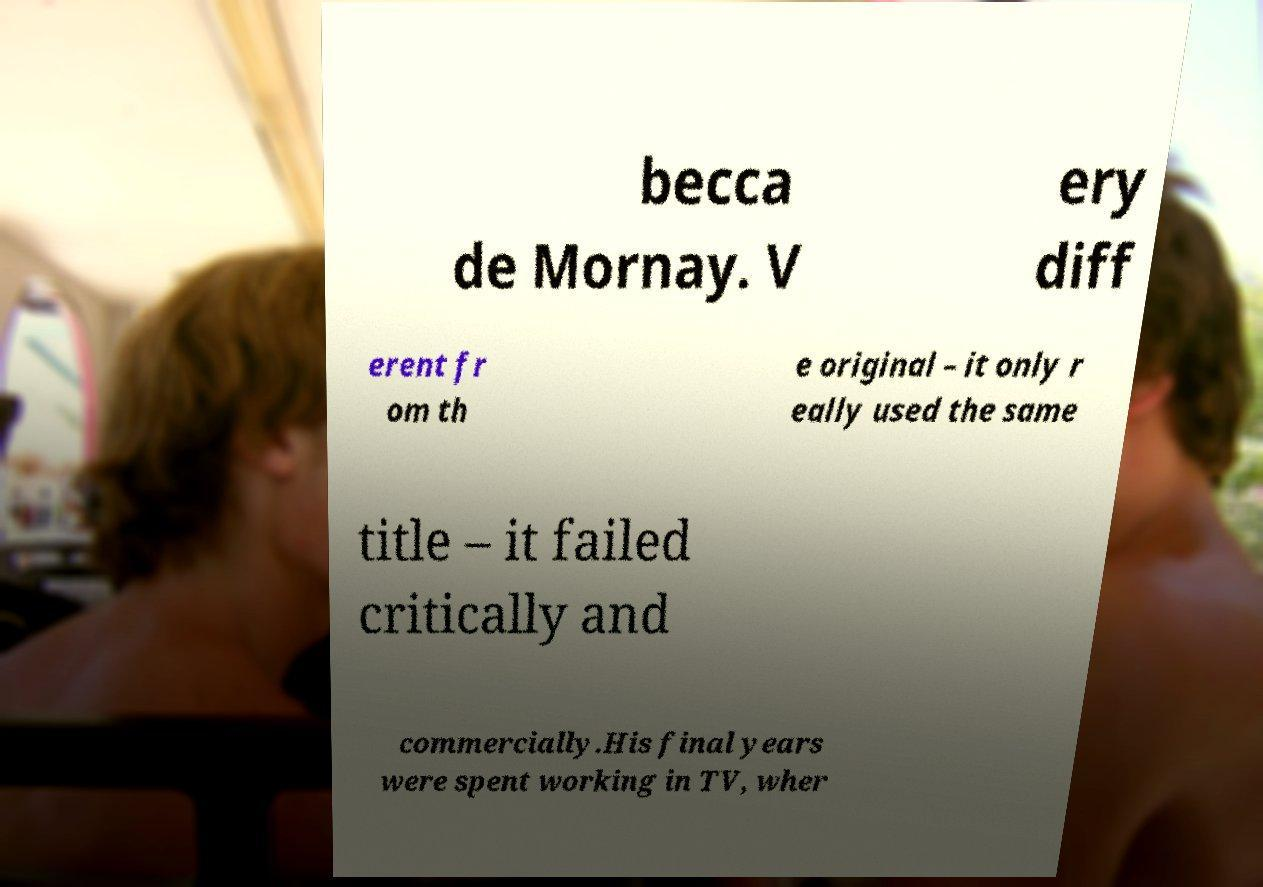For documentation purposes, I need the text within this image transcribed. Could you provide that? becca de Mornay. V ery diff erent fr om th e original – it only r eally used the same title – it failed critically and commercially.His final years were spent working in TV, wher 